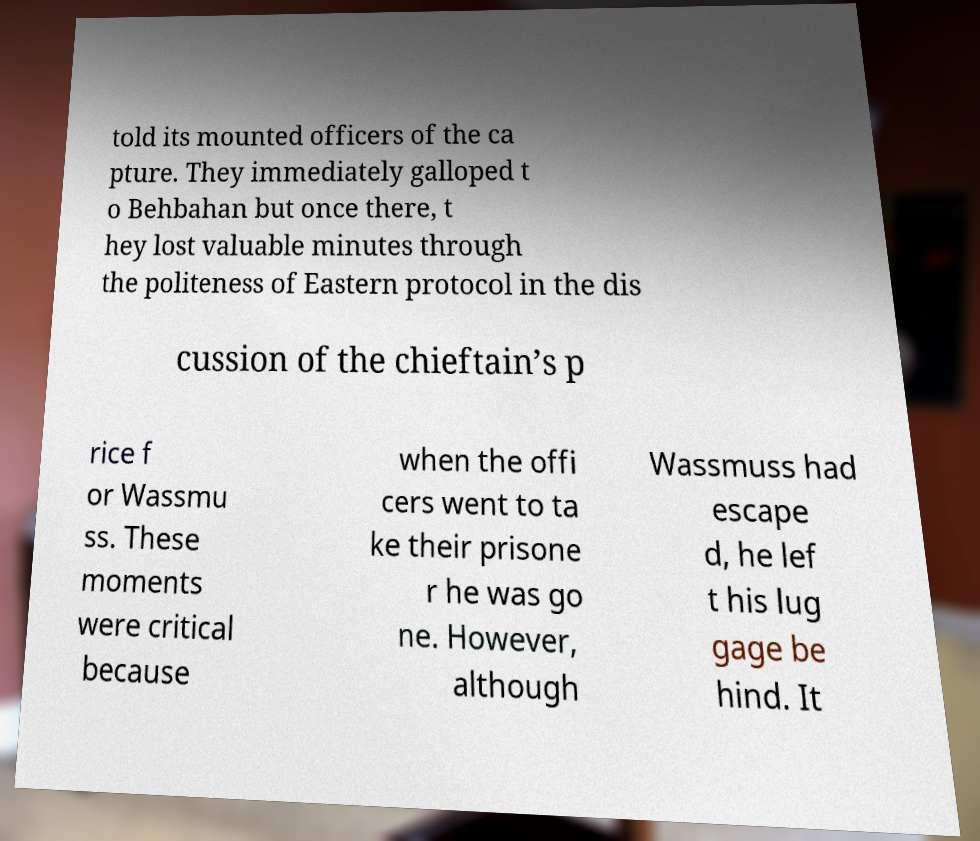Please identify and transcribe the text found in this image. told its mounted officers of the ca pture. They immediately galloped t o Behbahan but once there, t hey lost valuable minutes through the politeness of Eastern protocol in the dis cussion of the chieftain’s p rice f or Wassmu ss. These moments were critical because when the offi cers went to ta ke their prisone r he was go ne. However, although Wassmuss had escape d, he lef t his lug gage be hind. It 